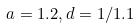<formula> <loc_0><loc_0><loc_500><loc_500>a = 1 . 2 , d = 1 / 1 . 1</formula> 